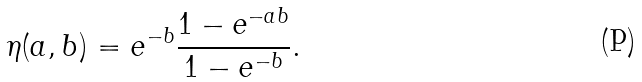<formula> <loc_0><loc_0><loc_500><loc_500>\eta ( a , b ) = e ^ { - b } \frac { 1 - e ^ { - a b } } { 1 - e ^ { - b } } .</formula> 